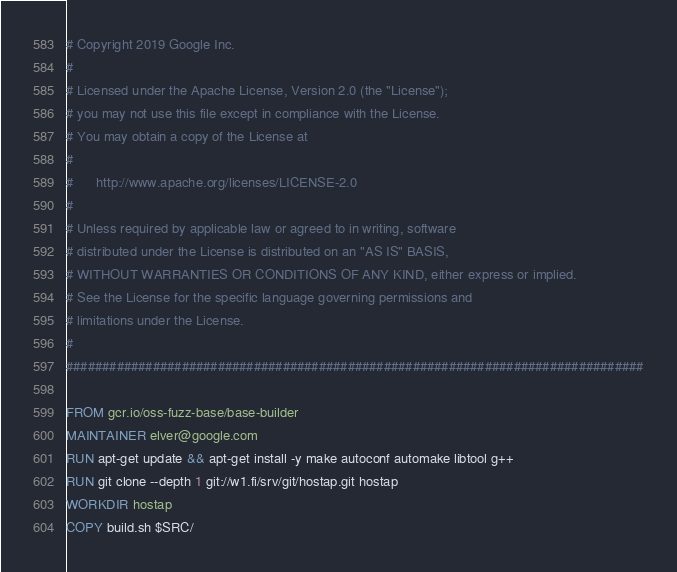<code> <loc_0><loc_0><loc_500><loc_500><_Dockerfile_># Copyright 2019 Google Inc.
#
# Licensed under the Apache License, Version 2.0 (the "License");
# you may not use this file except in compliance with the License.
# You may obtain a copy of the License at
#
#      http://www.apache.org/licenses/LICENSE-2.0
#
# Unless required by applicable law or agreed to in writing, software
# distributed under the License is distributed on an "AS IS" BASIS,
# WITHOUT WARRANTIES OR CONDITIONS OF ANY KIND, either express or implied.
# See the License for the specific language governing permissions and
# limitations under the License.
#
################################################################################

FROM gcr.io/oss-fuzz-base/base-builder
MAINTAINER elver@google.com
RUN apt-get update && apt-get install -y make autoconf automake libtool g++
RUN git clone --depth 1 git://w1.fi/srv/git/hostap.git hostap
WORKDIR hostap
COPY build.sh $SRC/
</code> 